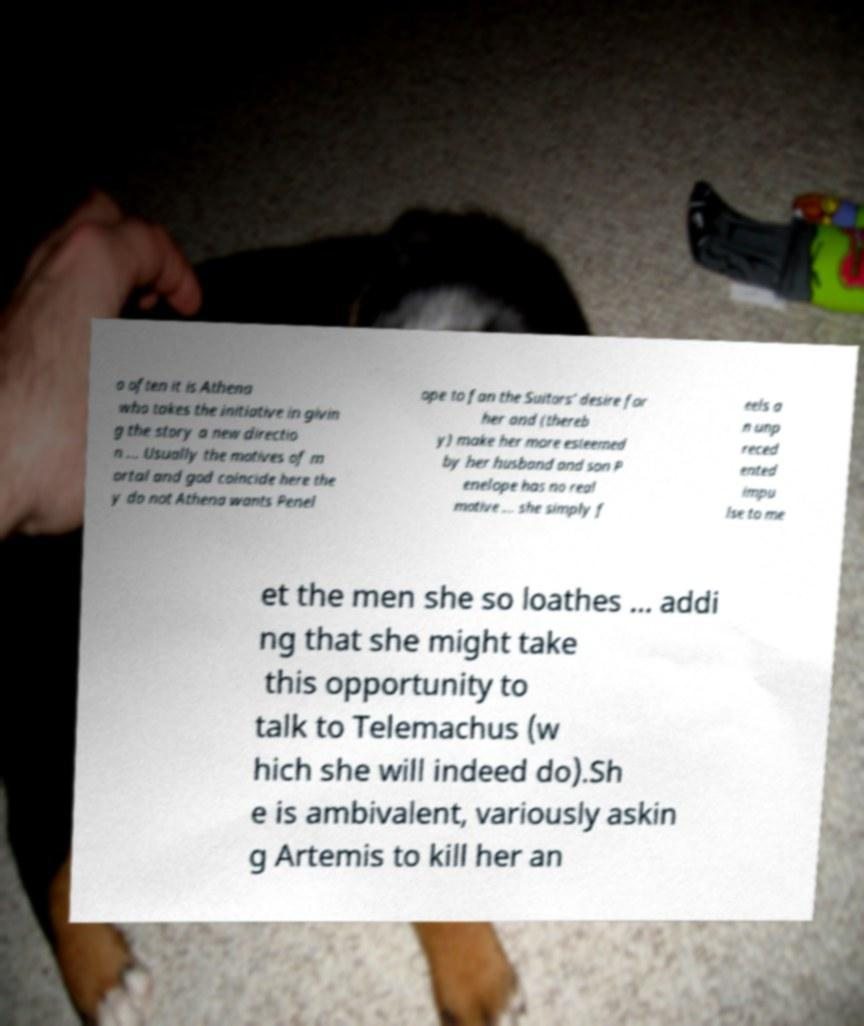Could you assist in decoding the text presented in this image and type it out clearly? o often it is Athena who takes the initiative in givin g the story a new directio n ... Usually the motives of m ortal and god coincide here the y do not Athena wants Penel ope to fan the Suitors’ desire for her and (thereb y) make her more esteemed by her husband and son P enelope has no real motive ... she simply f eels a n unp reced ented impu lse to me et the men she so loathes ... addi ng that she might take this opportunity to talk to Telemachus (w hich she will indeed do).Sh e is ambivalent, variously askin g Artemis to kill her an 